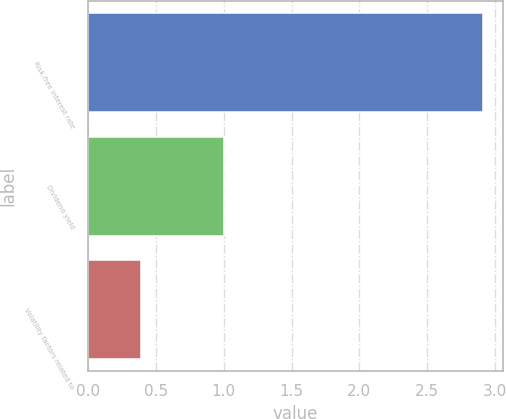Convert chart. <chart><loc_0><loc_0><loc_500><loc_500><bar_chart><fcel>Risk-free interest rate<fcel>Dividend yield<fcel>Volatility factors related to<nl><fcel>2.91<fcel>1<fcel>0.39<nl></chart> 